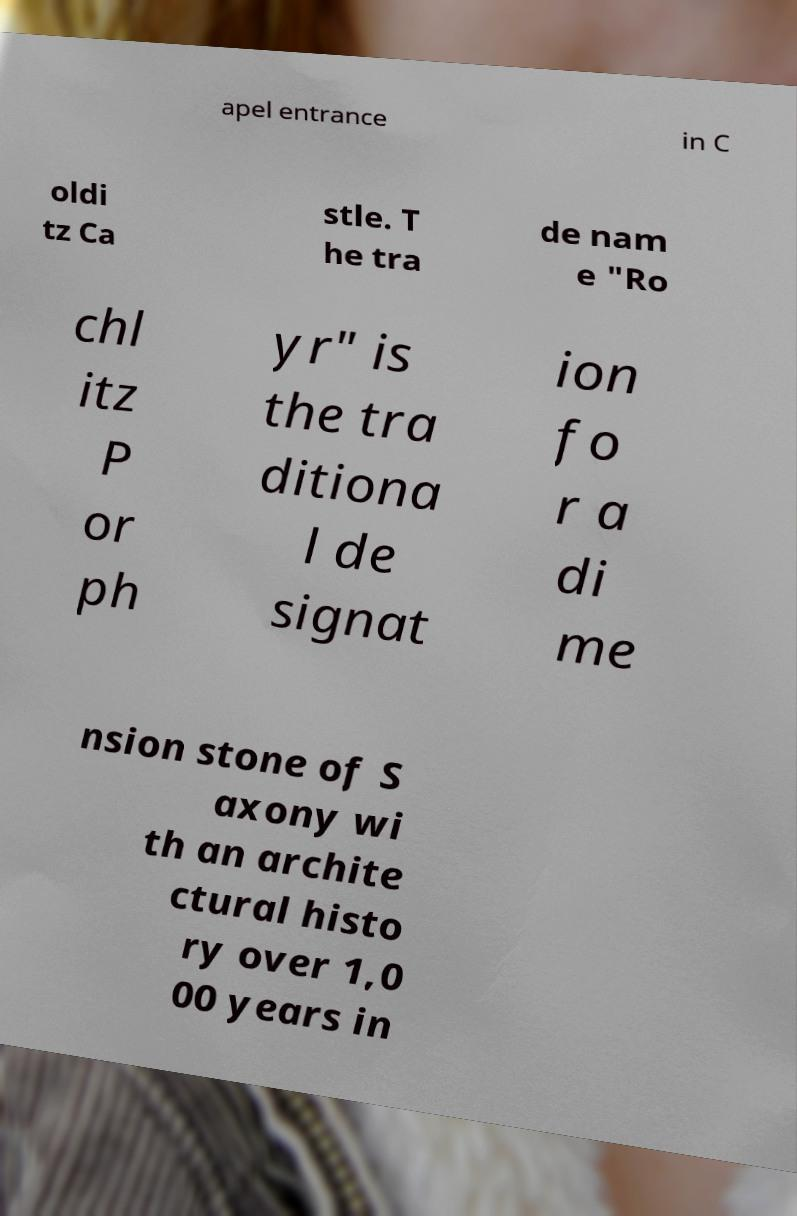Could you assist in decoding the text presented in this image and type it out clearly? apel entrance in C oldi tz Ca stle. T he tra de nam e "Ro chl itz P or ph yr" is the tra ditiona l de signat ion fo r a di me nsion stone of S axony wi th an archite ctural histo ry over 1,0 00 years in 